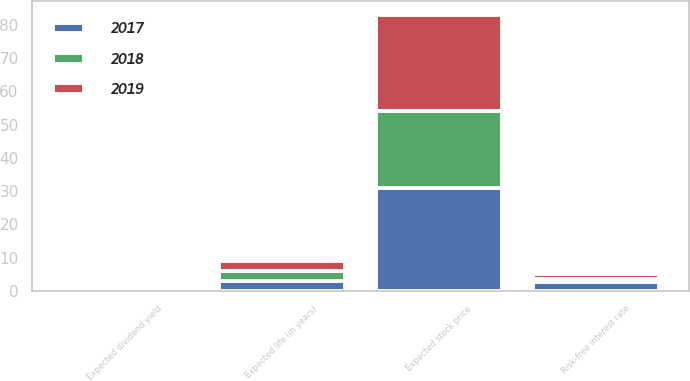Convert chart to OTSL. <chart><loc_0><loc_0><loc_500><loc_500><stacked_bar_chart><ecel><fcel>Expected stock price<fcel>Expected dividend yield<fcel>Risk-free interest rate<fcel>Expected life (in years)<nl><fcel>2017<fcel>31<fcel>0.9<fcel>2.6<fcel>3<nl><fcel>2019<fcel>29<fcel>0.8<fcel>1.5<fcel>3<nl><fcel>2018<fcel>23<fcel>0.7<fcel>1.1<fcel>3<nl></chart> 